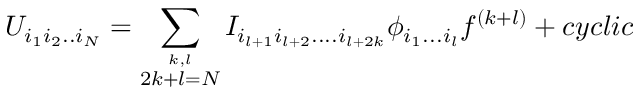Convert formula to latex. <formula><loc_0><loc_0><loc_500><loc_500>U _ { i _ { 1 } i _ { 2 } . . i _ { N } } = \sum _ { \stackrel { k , l } { 2 k + l = N } } I _ { i _ { l + 1 } i _ { l + 2 } \cdots i _ { l + 2 k } } \phi _ { i _ { 1 } \dots i _ { l } } f ^ { ( k + l ) } + c y c l i c</formula> 